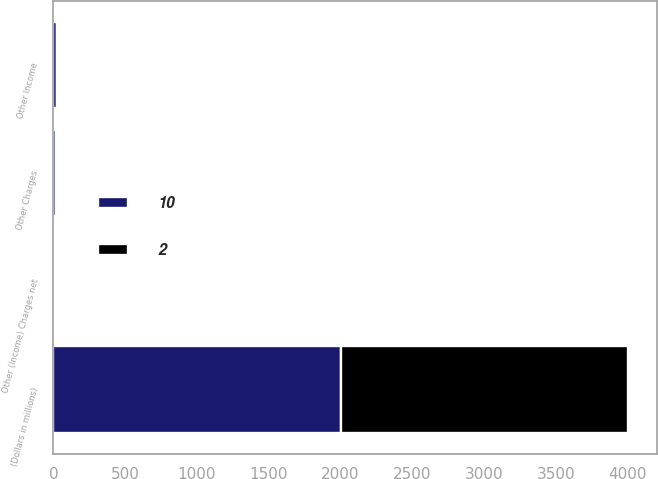Convert chart to OTSL. <chart><loc_0><loc_0><loc_500><loc_500><stacked_bar_chart><ecel><fcel>(Dollars in millions)<fcel>Other Income<fcel>Other Charges<fcel>Other (Income) Charges net<nl><fcel>10<fcel>2003<fcel>28<fcel>18<fcel>10<nl><fcel>2<fcel>2002<fcel>14<fcel>16<fcel>2<nl></chart> 